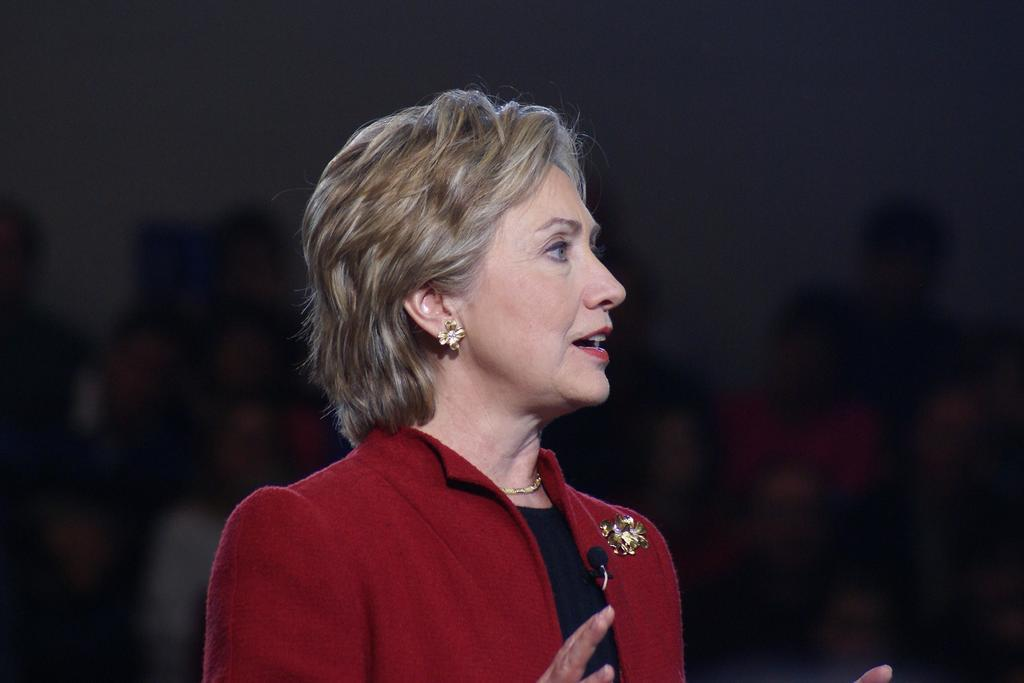What is the main subject of the image? The main subject of the image is a woman. What is the woman doing in the image? The woman is standing and speaking into a microphone. How is the microphone attached to the woman? The microphone is attached to her coat. What color is the woman's coat? The woman is wearing a red-colored coat. What type of wool is being sold in the shop that is visible in the image? There is no shop or wool present in the image; it features a woman wearing a red-colored coat and speaking into a microphone. What sound does the horn make in the image? There is no horn present in the image. 